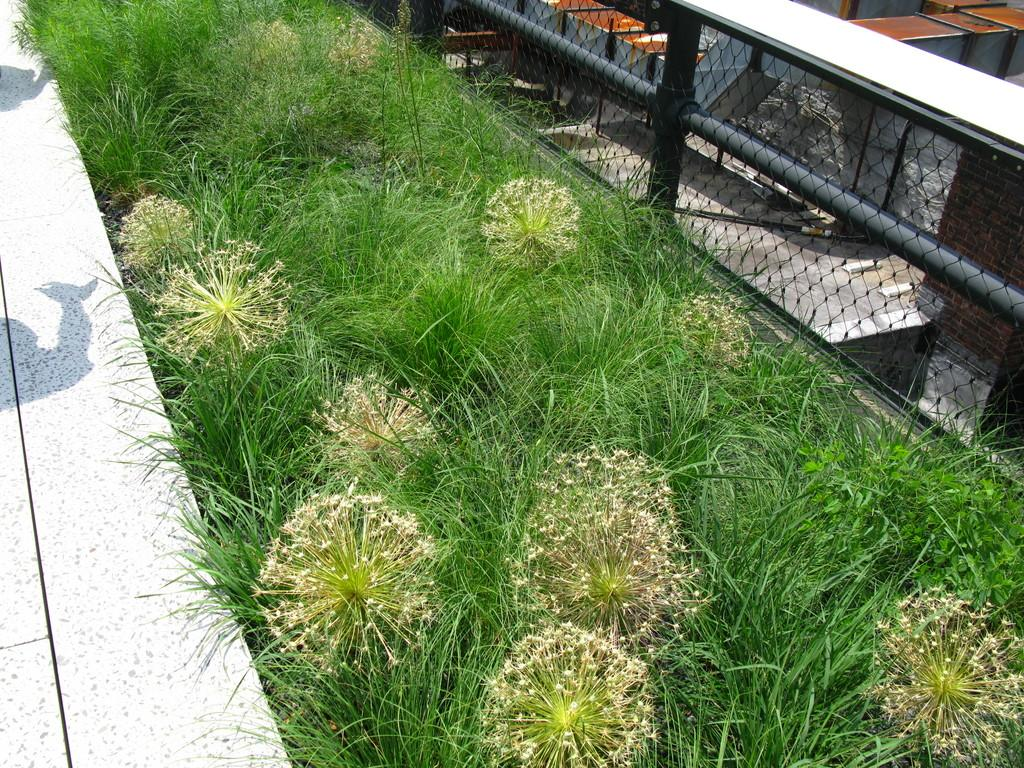What type of vegetation is visible in the front of the image? There is grass in the front of the image. What material is the fence on the right side of the image made of? The fence on the right side of the image is made of metal. Can you describe the color of any objects in the image? There are objects with a brown color in the image. What type of skin condition can be seen on the objects with a brown color in the image? There is no skin condition present in the image, as the objects with a brown color are not living organisms. What type of journey is being taken by the yoke in the image? There is no yoke present in the image, as it is not mentioned in the provided facts. 